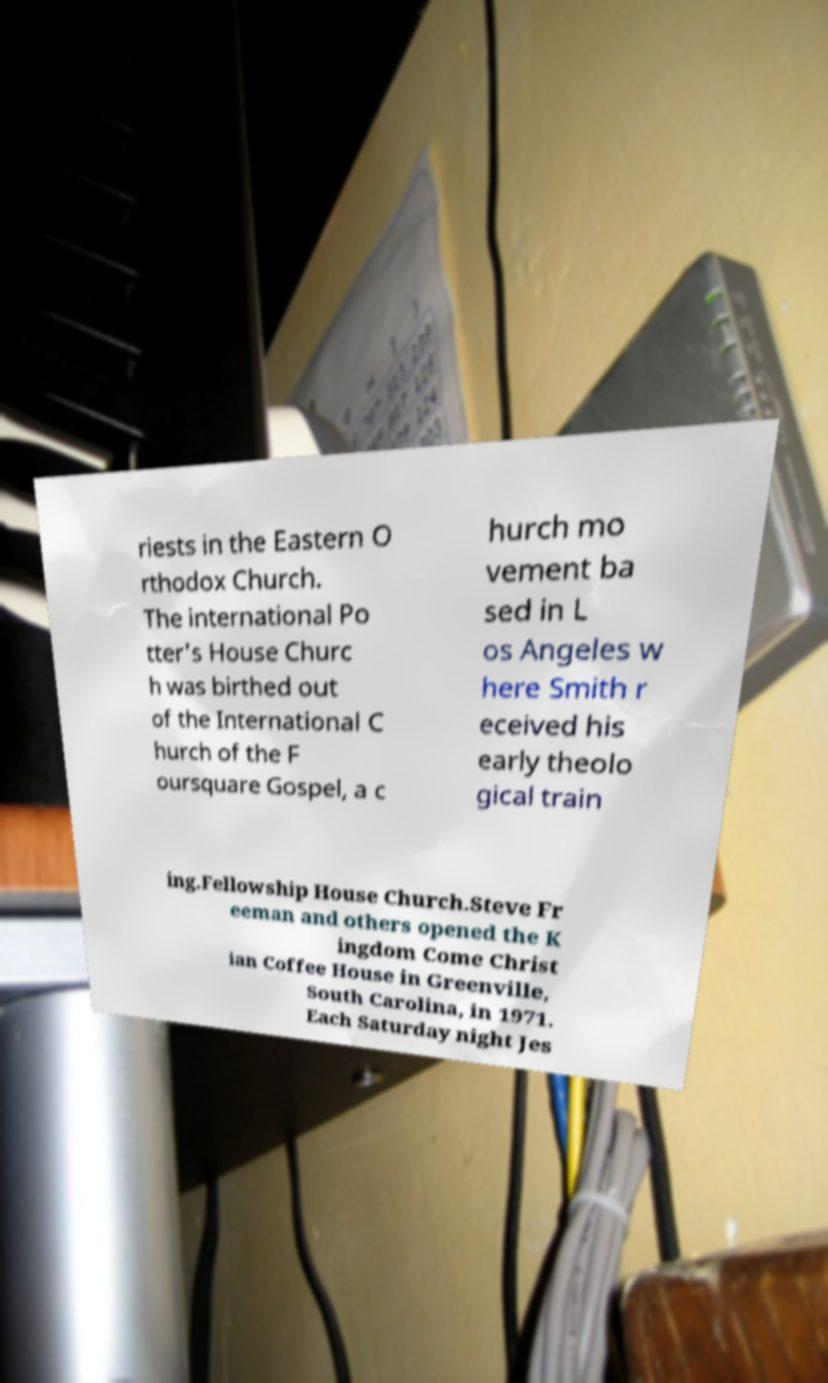Could you assist in decoding the text presented in this image and type it out clearly? riests in the Eastern O rthodox Church. The international Po tter's House Churc h was birthed out of the International C hurch of the F oursquare Gospel, a c hurch mo vement ba sed in L os Angeles w here Smith r eceived his early theolo gical train ing.Fellowship House Church.Steve Fr eeman and others opened the K ingdom Come Christ ian Coffee House in Greenville, South Carolina, in 1971. Each Saturday night Jes 